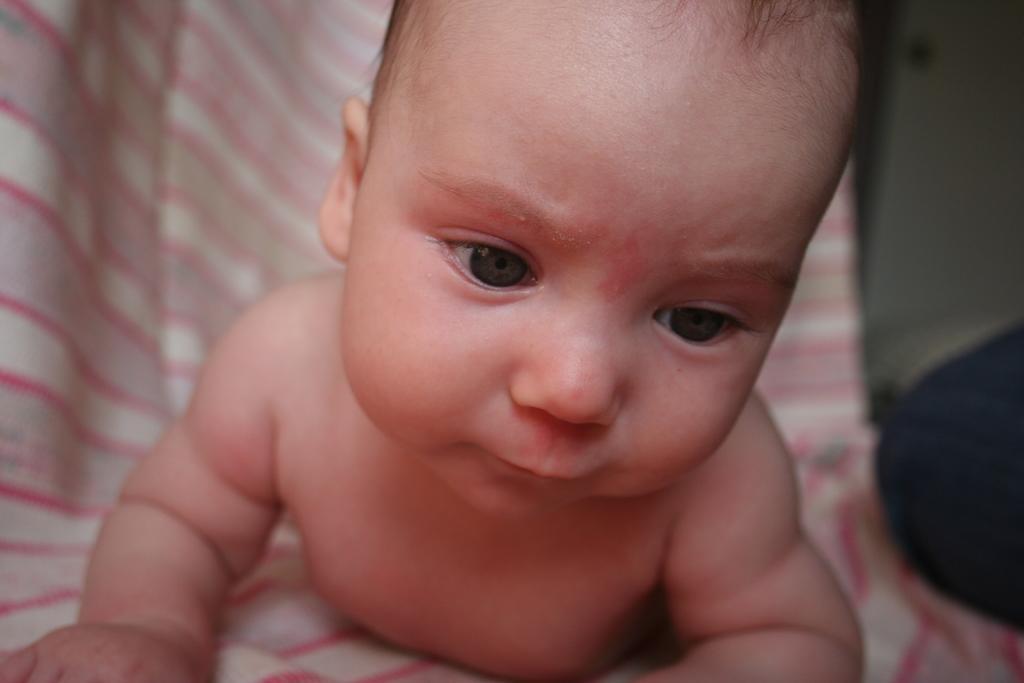How would you summarize this image in a sentence or two? In the center of the image there is a baby. 